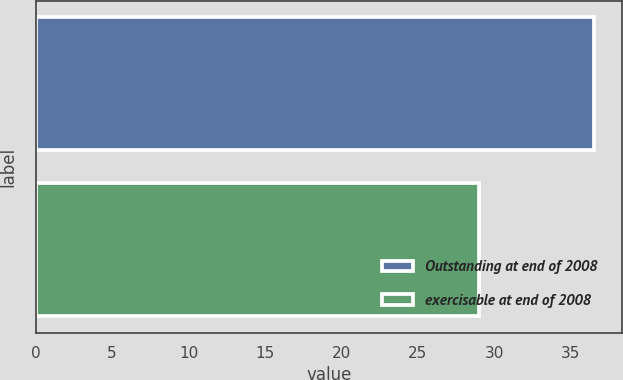<chart> <loc_0><loc_0><loc_500><loc_500><bar_chart><fcel>Outstanding at end of 2008<fcel>exercisable at end of 2008<nl><fcel>36.52<fcel>29.04<nl></chart> 